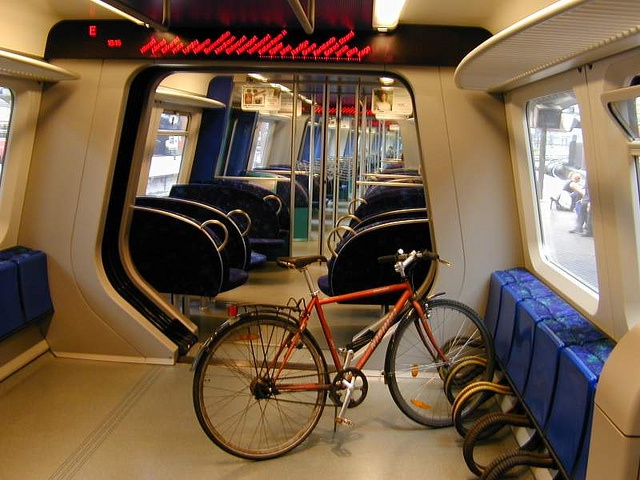Describe the objects in this image and their specific colors. I can see bicycle in tan, black, olive, and maroon tones, chair in tan, navy, black, and blue tones, chair in tan, navy, black, blue, and darkblue tones, chair in tan, black, gray, and darkgray tones, and chair in tan, black, gray, and maroon tones in this image. 